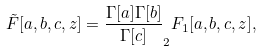Convert formula to latex. <formula><loc_0><loc_0><loc_500><loc_500>\tilde { F } [ a , b , c , z ] = \frac { \Gamma [ a ] \Gamma [ b ] } { \Gamma [ c ] } _ { 2 } F _ { 1 } [ a , b , c , z ] ,</formula> 